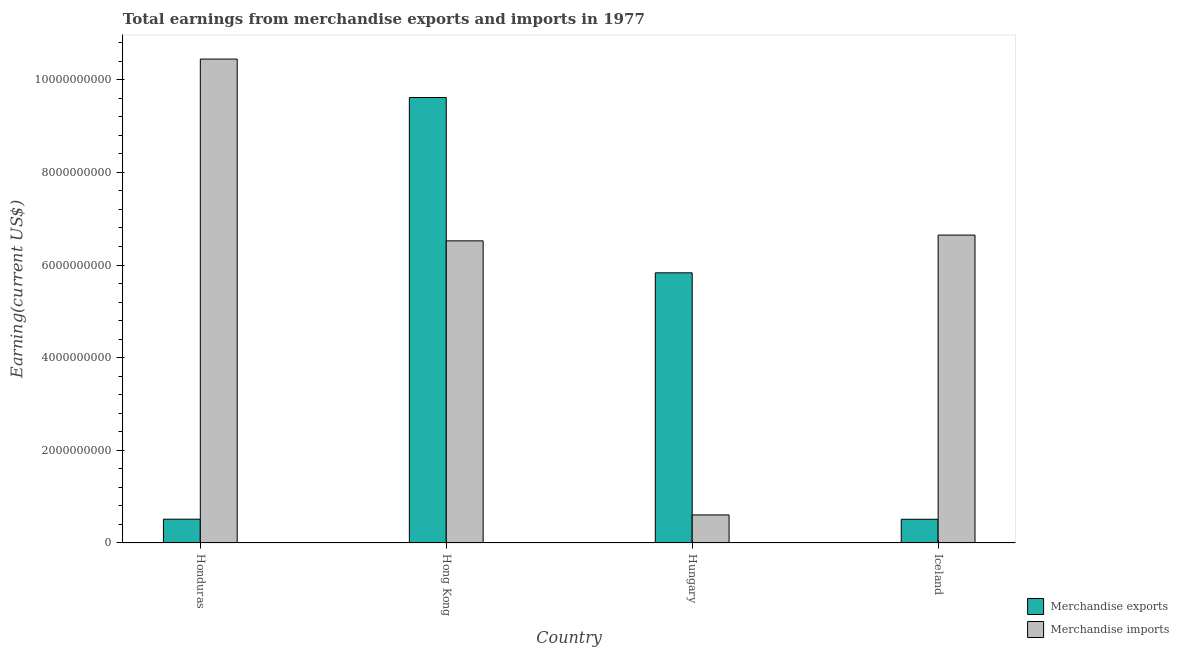How many groups of bars are there?
Provide a succinct answer. 4. Are the number of bars per tick equal to the number of legend labels?
Offer a very short reply. Yes. How many bars are there on the 4th tick from the left?
Your response must be concise. 2. What is the earnings from merchandise exports in Hong Kong?
Your answer should be very brief. 9.62e+09. Across all countries, what is the maximum earnings from merchandise imports?
Ensure brevity in your answer.  1.04e+1. Across all countries, what is the minimum earnings from merchandise imports?
Ensure brevity in your answer.  6.05e+08. In which country was the earnings from merchandise exports maximum?
Provide a short and direct response. Hong Kong. What is the total earnings from merchandise imports in the graph?
Your response must be concise. 2.42e+1. What is the difference between the earnings from merchandise imports in Honduras and that in Hungary?
Provide a short and direct response. 9.84e+09. What is the difference between the earnings from merchandise exports in Honduras and the earnings from merchandise imports in Iceland?
Offer a terse response. -6.13e+09. What is the average earnings from merchandise imports per country?
Provide a succinct answer. 6.06e+09. What is the difference between the earnings from merchandise imports and earnings from merchandise exports in Hong Kong?
Make the answer very short. -3.09e+09. What is the ratio of the earnings from merchandise imports in Hong Kong to that in Hungary?
Keep it short and to the point. 10.77. Is the earnings from merchandise imports in Honduras less than that in Hong Kong?
Offer a very short reply. No. What is the difference between the highest and the second highest earnings from merchandise imports?
Ensure brevity in your answer.  3.80e+09. What is the difference between the highest and the lowest earnings from merchandise imports?
Your answer should be very brief. 9.84e+09. In how many countries, is the earnings from merchandise imports greater than the average earnings from merchandise imports taken over all countries?
Keep it short and to the point. 3. What does the 2nd bar from the left in Hungary represents?
Your answer should be compact. Merchandise imports. What does the 1st bar from the right in Hong Kong represents?
Your answer should be compact. Merchandise imports. Are all the bars in the graph horizontal?
Offer a very short reply. No. Are the values on the major ticks of Y-axis written in scientific E-notation?
Provide a short and direct response. No. Does the graph contain any zero values?
Keep it short and to the point. No. How many legend labels are there?
Your response must be concise. 2. How are the legend labels stacked?
Provide a succinct answer. Vertical. What is the title of the graph?
Provide a short and direct response. Total earnings from merchandise exports and imports in 1977. Does "Netherlands" appear as one of the legend labels in the graph?
Make the answer very short. No. What is the label or title of the Y-axis?
Offer a terse response. Earning(current US$). What is the Earning(current US$) of Merchandise exports in Honduras?
Your answer should be very brief. 5.13e+08. What is the Earning(current US$) of Merchandise imports in Honduras?
Offer a very short reply. 1.04e+1. What is the Earning(current US$) of Merchandise exports in Hong Kong?
Make the answer very short. 9.62e+09. What is the Earning(current US$) of Merchandise imports in Hong Kong?
Keep it short and to the point. 6.52e+09. What is the Earning(current US$) in Merchandise exports in Hungary?
Provide a short and direct response. 5.83e+09. What is the Earning(current US$) in Merchandise imports in Hungary?
Keep it short and to the point. 6.05e+08. What is the Earning(current US$) in Merchandise exports in Iceland?
Give a very brief answer. 5.12e+08. What is the Earning(current US$) of Merchandise imports in Iceland?
Ensure brevity in your answer.  6.65e+09. Across all countries, what is the maximum Earning(current US$) in Merchandise exports?
Your response must be concise. 9.62e+09. Across all countries, what is the maximum Earning(current US$) in Merchandise imports?
Your answer should be very brief. 1.04e+1. Across all countries, what is the minimum Earning(current US$) of Merchandise exports?
Provide a succinct answer. 5.12e+08. Across all countries, what is the minimum Earning(current US$) of Merchandise imports?
Your answer should be very brief. 6.05e+08. What is the total Earning(current US$) of Merchandise exports in the graph?
Offer a terse response. 1.65e+1. What is the total Earning(current US$) in Merchandise imports in the graph?
Make the answer very short. 2.42e+1. What is the difference between the Earning(current US$) of Merchandise exports in Honduras and that in Hong Kong?
Offer a very short reply. -9.10e+09. What is the difference between the Earning(current US$) of Merchandise imports in Honduras and that in Hong Kong?
Give a very brief answer. 3.92e+09. What is the difference between the Earning(current US$) in Merchandise exports in Honduras and that in Hungary?
Your response must be concise. -5.32e+09. What is the difference between the Earning(current US$) in Merchandise imports in Honduras and that in Hungary?
Make the answer very short. 9.84e+09. What is the difference between the Earning(current US$) in Merchandise exports in Honduras and that in Iceland?
Your response must be concise. 1.43e+06. What is the difference between the Earning(current US$) in Merchandise imports in Honduras and that in Iceland?
Your answer should be very brief. 3.80e+09. What is the difference between the Earning(current US$) of Merchandise exports in Hong Kong and that in Hungary?
Keep it short and to the point. 3.78e+09. What is the difference between the Earning(current US$) in Merchandise imports in Hong Kong and that in Hungary?
Ensure brevity in your answer.  5.92e+09. What is the difference between the Earning(current US$) in Merchandise exports in Hong Kong and that in Iceland?
Provide a short and direct response. 9.10e+09. What is the difference between the Earning(current US$) of Merchandise imports in Hong Kong and that in Iceland?
Ensure brevity in your answer.  -1.25e+08. What is the difference between the Earning(current US$) of Merchandise exports in Hungary and that in Iceland?
Offer a terse response. 5.32e+09. What is the difference between the Earning(current US$) in Merchandise imports in Hungary and that in Iceland?
Provide a short and direct response. -6.04e+09. What is the difference between the Earning(current US$) of Merchandise exports in Honduras and the Earning(current US$) of Merchandise imports in Hong Kong?
Give a very brief answer. -6.01e+09. What is the difference between the Earning(current US$) in Merchandise exports in Honduras and the Earning(current US$) in Merchandise imports in Hungary?
Make the answer very short. -9.20e+07. What is the difference between the Earning(current US$) of Merchandise exports in Honduras and the Earning(current US$) of Merchandise imports in Iceland?
Your response must be concise. -6.13e+09. What is the difference between the Earning(current US$) in Merchandise exports in Hong Kong and the Earning(current US$) in Merchandise imports in Hungary?
Provide a short and direct response. 9.01e+09. What is the difference between the Earning(current US$) of Merchandise exports in Hong Kong and the Earning(current US$) of Merchandise imports in Iceland?
Your answer should be compact. 2.97e+09. What is the difference between the Earning(current US$) of Merchandise exports in Hungary and the Earning(current US$) of Merchandise imports in Iceland?
Offer a terse response. -8.15e+08. What is the average Earning(current US$) in Merchandise exports per country?
Offer a terse response. 4.12e+09. What is the average Earning(current US$) of Merchandise imports per country?
Offer a terse response. 6.06e+09. What is the difference between the Earning(current US$) in Merchandise exports and Earning(current US$) in Merchandise imports in Honduras?
Provide a short and direct response. -9.93e+09. What is the difference between the Earning(current US$) in Merchandise exports and Earning(current US$) in Merchandise imports in Hong Kong?
Your response must be concise. 3.09e+09. What is the difference between the Earning(current US$) of Merchandise exports and Earning(current US$) of Merchandise imports in Hungary?
Provide a succinct answer. 5.23e+09. What is the difference between the Earning(current US$) in Merchandise exports and Earning(current US$) in Merchandise imports in Iceland?
Your answer should be compact. -6.13e+09. What is the ratio of the Earning(current US$) of Merchandise exports in Honduras to that in Hong Kong?
Your answer should be compact. 0.05. What is the ratio of the Earning(current US$) in Merchandise imports in Honduras to that in Hong Kong?
Give a very brief answer. 1.6. What is the ratio of the Earning(current US$) of Merchandise exports in Honduras to that in Hungary?
Provide a short and direct response. 0.09. What is the ratio of the Earning(current US$) of Merchandise imports in Honduras to that in Hungary?
Provide a short and direct response. 17.25. What is the ratio of the Earning(current US$) in Merchandise imports in Honduras to that in Iceland?
Offer a terse response. 1.57. What is the ratio of the Earning(current US$) of Merchandise exports in Hong Kong to that in Hungary?
Your answer should be compact. 1.65. What is the ratio of the Earning(current US$) of Merchandise imports in Hong Kong to that in Hungary?
Make the answer very short. 10.77. What is the ratio of the Earning(current US$) in Merchandise exports in Hong Kong to that in Iceland?
Your answer should be very brief. 18.78. What is the ratio of the Earning(current US$) of Merchandise imports in Hong Kong to that in Iceland?
Offer a terse response. 0.98. What is the ratio of the Earning(current US$) of Merchandise exports in Hungary to that in Iceland?
Give a very brief answer. 11.39. What is the ratio of the Earning(current US$) of Merchandise imports in Hungary to that in Iceland?
Provide a succinct answer. 0.09. What is the difference between the highest and the second highest Earning(current US$) in Merchandise exports?
Your response must be concise. 3.78e+09. What is the difference between the highest and the second highest Earning(current US$) of Merchandise imports?
Keep it short and to the point. 3.80e+09. What is the difference between the highest and the lowest Earning(current US$) of Merchandise exports?
Your response must be concise. 9.10e+09. What is the difference between the highest and the lowest Earning(current US$) of Merchandise imports?
Offer a terse response. 9.84e+09. 